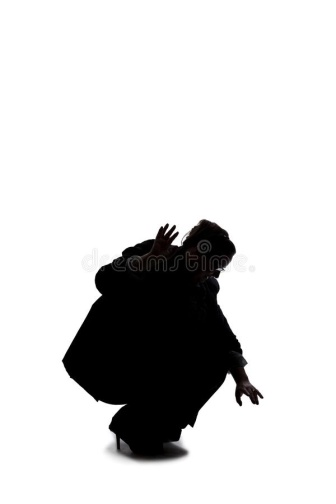A very creative question to spark imaginative thinking. If the silhouette in the image were actually a shadow of a mythical creature that can only be seen in the moonlight, what creature would it be, and what is the legend behind its appearance? Legend speaks of the Mythril Wraith, a creature woven from the ethereal threads of moonlight, whose form can only be glimpsed when the moon is at its zenith. It is said that the Wraith is a guardian of ancient secrets, prowling the edge of reality and the unseen realms. Its silhouette, although human-like, hints at its otherworldly nature with elongating limbs and tendrils of spectral energy that shimmer faintly. The legend tells of how the Wraith appears at moments of great cosmic significance or when the balance between light and darkness is threatened. It traverses the silent white expanses, like the one in the image, seeking out lost artifacts and forgotten memories to restore harmony. Those fortunate (or unfortunate) enough to witness the Wraith's silhouette are believed to be marked for a quest of great importance, one that could save or doom their world. 